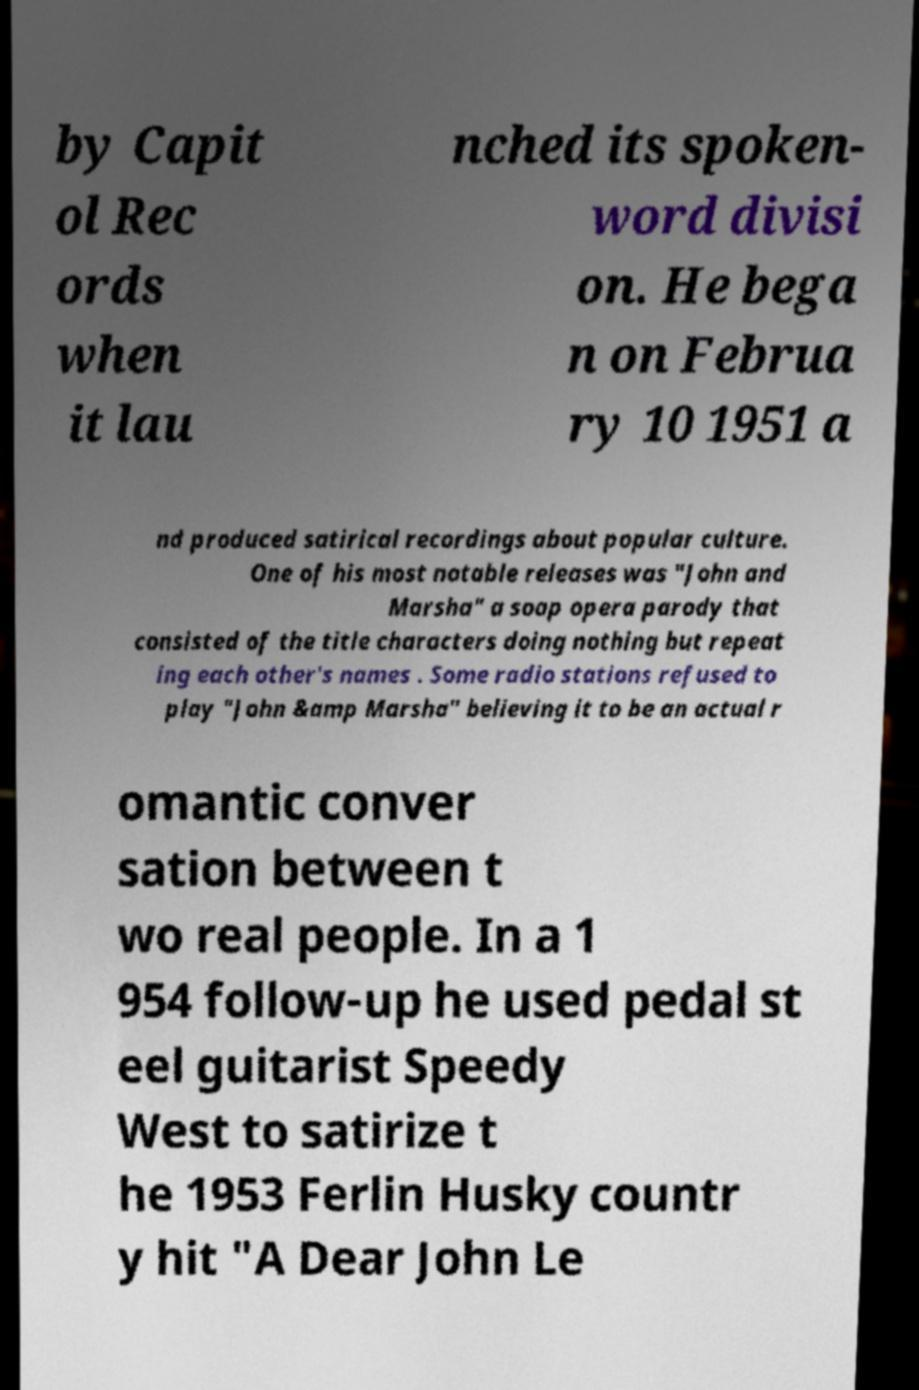Could you assist in decoding the text presented in this image and type it out clearly? by Capit ol Rec ords when it lau nched its spoken- word divisi on. He bega n on Februa ry 10 1951 a nd produced satirical recordings about popular culture. One of his most notable releases was "John and Marsha" a soap opera parody that consisted of the title characters doing nothing but repeat ing each other's names . Some radio stations refused to play "John &amp Marsha" believing it to be an actual r omantic conver sation between t wo real people. In a 1 954 follow-up he used pedal st eel guitarist Speedy West to satirize t he 1953 Ferlin Husky countr y hit "A Dear John Le 